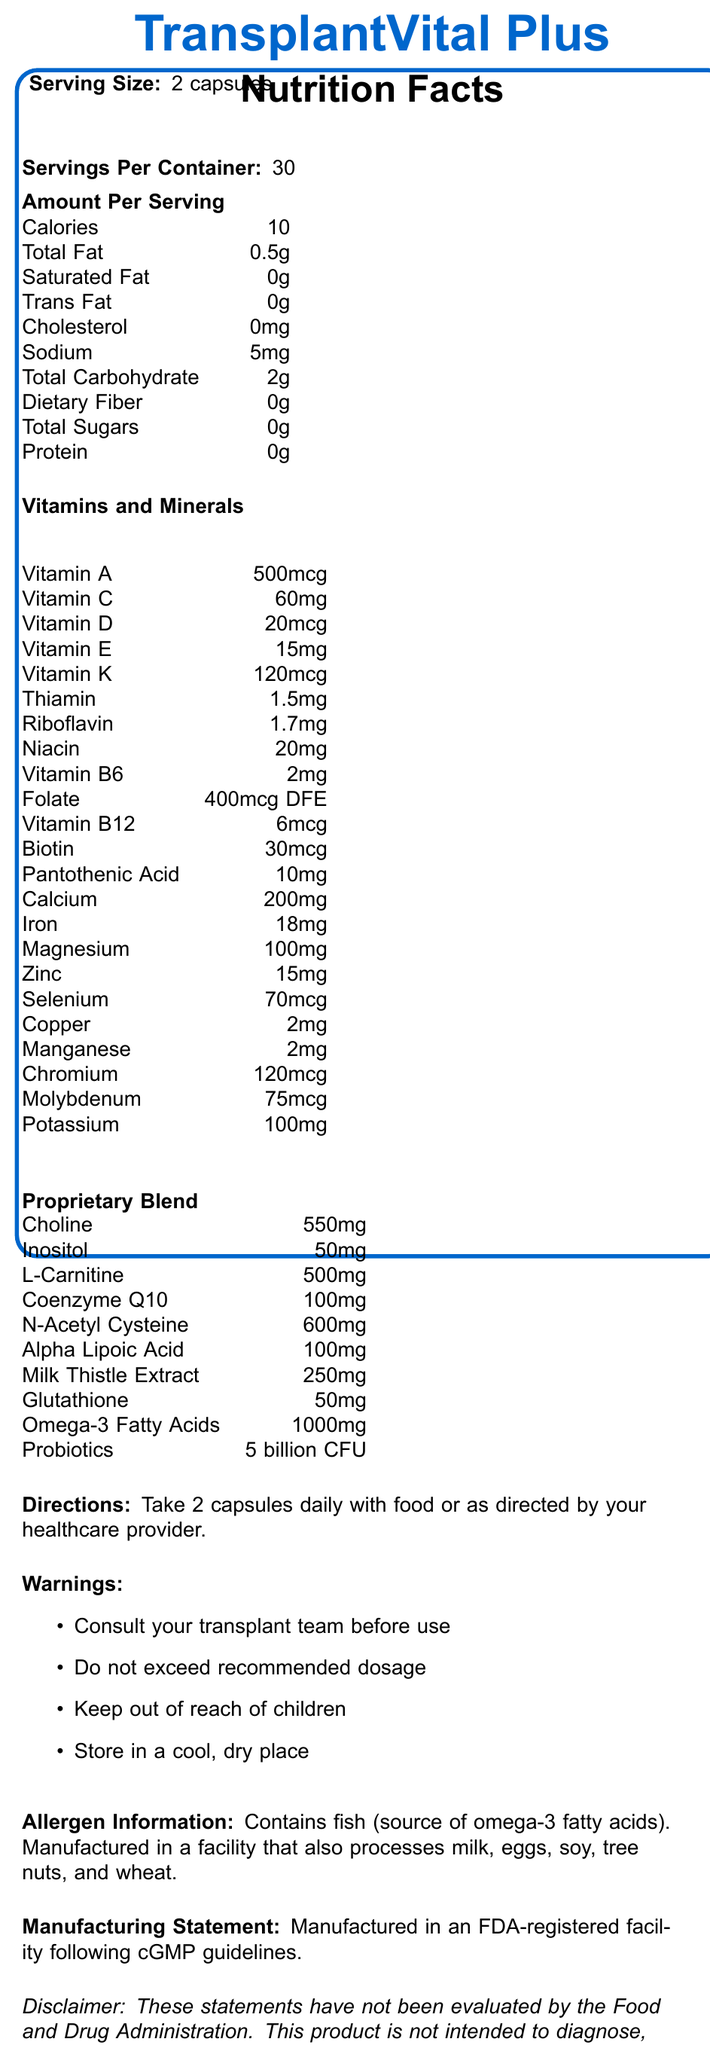what is the serving size? The serving size is stated clearly as "2 capsules".
Answer: 2 capsules how many calories are in a serving? The number of calories per serving is listed as 10.
Answer: 10 what is the total fat content per serving? The total fat content per serving is provided as 0.5g.
Answer: 0.5g does the product contain any protein? The document lists protein content per serving as 0g.
Answer: No how much sodium is in each serving? The sodium content per serving is given as 5mg.
Answer: 5mg what is the recommended daily dosage? The directions state to "Take 2 capsules daily with food or as directed by your healthcare provider."
Answer: 2 capsules daily with food or as directed by your healthcare provider which type of organ transplant recipients is this supplement specifically formulated for? A. Liver B. Kidney C. Heart D. All of the above The product is formulated to support the nutritional needs of organ transplant recipients, which includes liver, kidney, and heart.
Answer: D what is the source of omega-3 fatty acids in this product? A. Fish B. Plants C. Algae D. Flaxseed The allergen information specifies that the product contains fish (source of omega-3 fatty acids).
Answer: A is the product manufactured in a GMP facility? The manufacturing statement indicates that it is manufactured in an FDA-registered facility following cGMP guidelines.
Answer: Yes is there any cholesterol in the product? The cholesterol content is listed as 0mg per serving.
Answer: No summarize the main idea of the document. The document lays out the comprehensive nutritional and supplemental components of TransplantVital Plus, detailing its purpose for transplant recipients, specific nutrient values, proprietary blend ingredients, usage directions, warnings, allergen information, and manufacturing standards.
Answer: The document provides detailed nutrition facts and information about TransplantVital Plus, a dietary supplement formulated for organ transplant recipients. It includes serving size, calories, macro and micronutrient content, proprietary blend components, and warnings. The supplement supports overall health and specific organ functions post-transplantation and is manufactured following FDA and cGMP guidelines. how many servings are there per container? The document clearly states that there are 30 servings per container.
Answer: 30 does the document mention anything about the product’s effectiveness in diagnosing, treating, curing, or preventing diseases? The disclaimer explicitly states that these statements have not been evaluated by the FDA and that the product is not intended to diagnose, treat, cure, or prevent any disease.
Answer: No how much iron is in each serving? The iron content per serving is listed as 18mg.
Answer: 18mg what is the amount of vitamin C per serving? The vitamin C content per serving is provided as 60mg.
Answer: 60mg how should the product be stored? A. In direct sunlight B. In a freezer C. In a cool, dry place D. In a hot environment The warnings specify that the product should be "Store[d] in a cool, dry place."
Answer: C does this product contain any dietary fiber? The dietary fiber content is listed as 0g per serving.
Answer: No how much vitamin D is in one serving? The document lists 20mcg of vitamin D per serving.
Answer: 20mcg what is the main purpose of this dietary supplement? The product description states that TransplantVital Plus is formulated to support the nutritional needs of organ transplant recipients.
Answer: To support the nutritional needs of organ transplant recipients how many calories are derived from fat per serving? The document does not provide specific information on how many of the 10 calories are derived from the 0.5g of total fat content.
Answer: Cannot be determined 